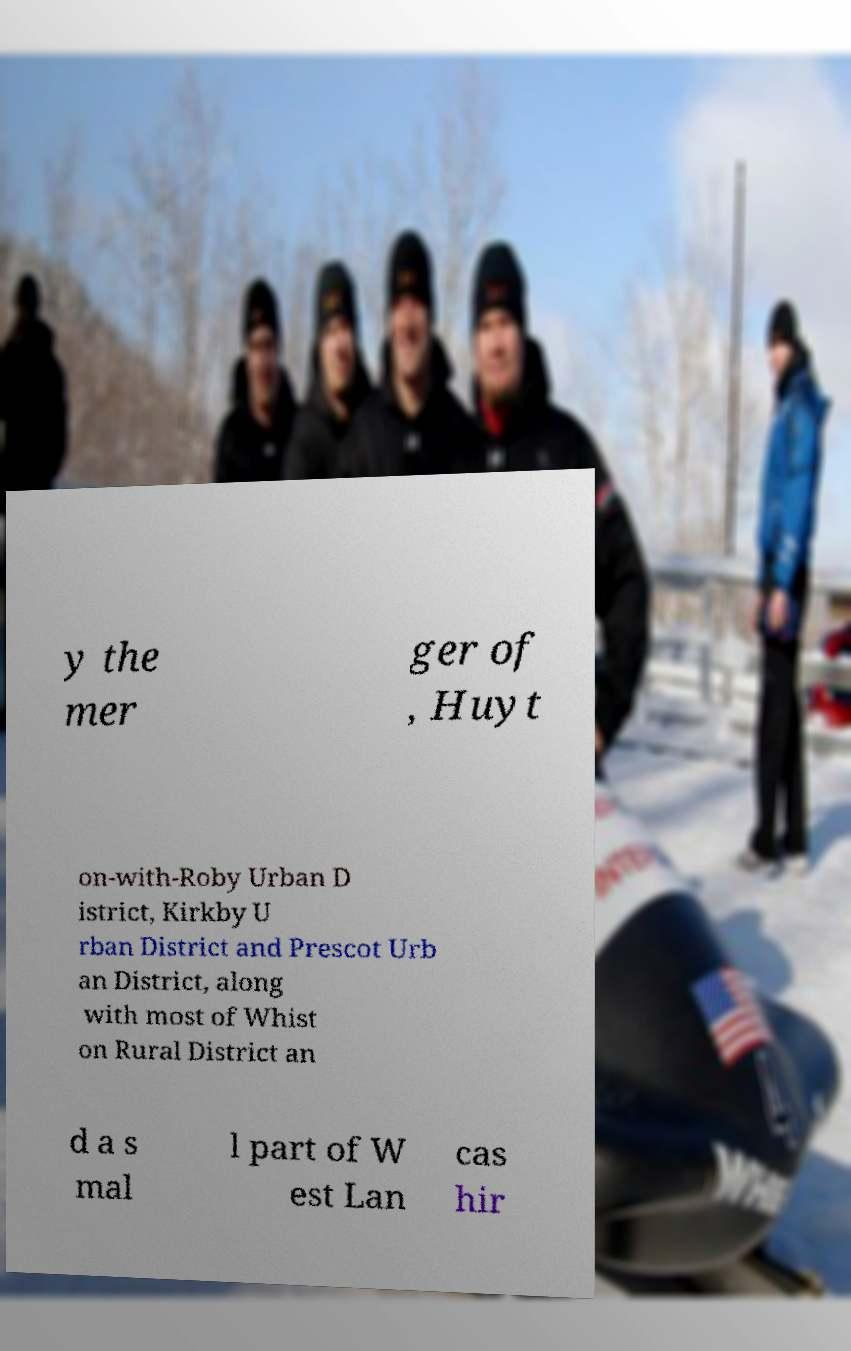Could you assist in decoding the text presented in this image and type it out clearly? y the mer ger of , Huyt on-with-Roby Urban D istrict, Kirkby U rban District and Prescot Urb an District, along with most of Whist on Rural District an d a s mal l part of W est Lan cas hir 